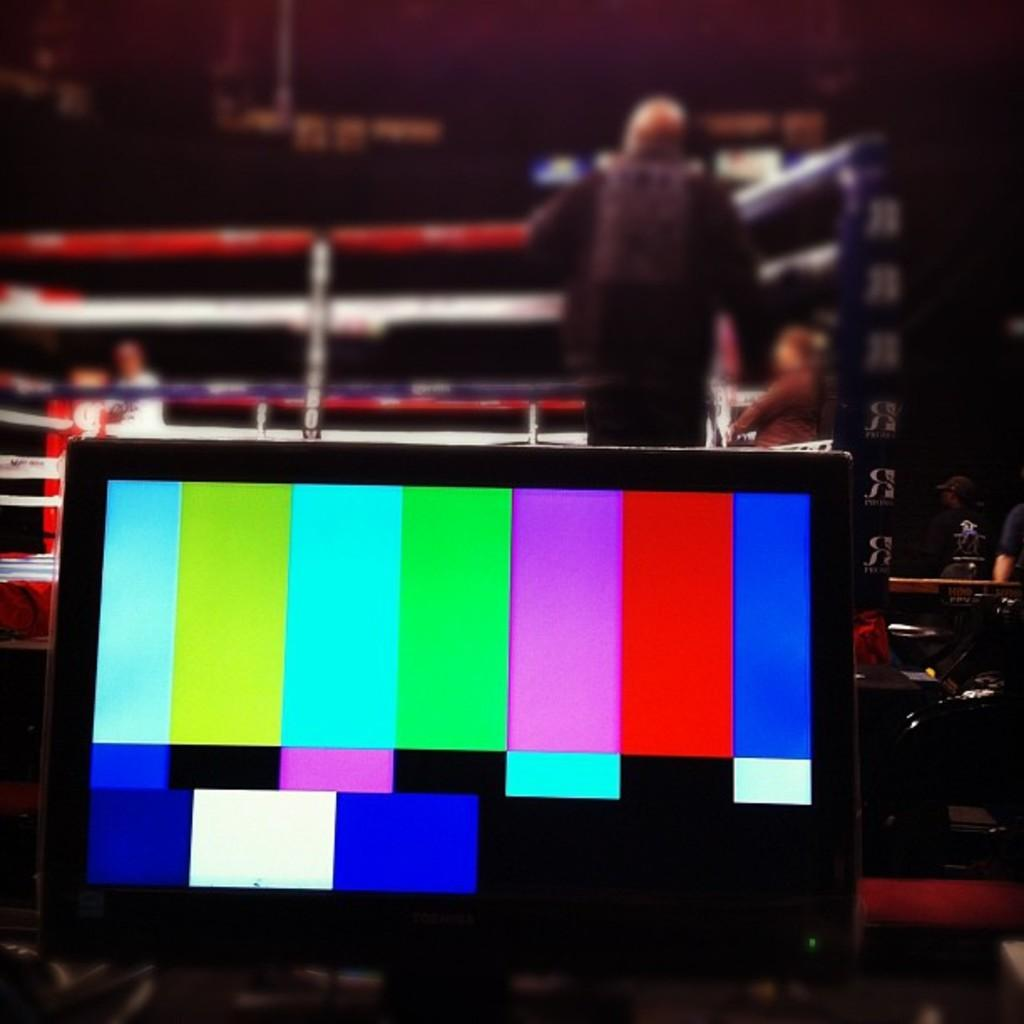What is the main object in the image? There is a screen in the image. Are there any people present in the image? Yes, there are people standing in the image. How would you describe the lighting in the image? The image appears to be a little dark. What type of tooth is being used to play the bells in the image? There are no teeth or bells present in the image. What is the whip used for in the image? There is no whip present in the image. 